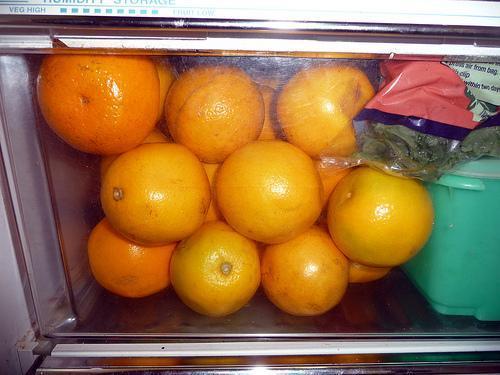How many containers are there?
Give a very brief answer. 1. 